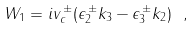<formula> <loc_0><loc_0><loc_500><loc_500>W _ { 1 } = i v _ { c } ^ { \, \pm } ( \epsilon _ { 2 } ^ { \, \pm } k _ { 3 } - \epsilon _ { 3 } ^ { \, \pm } k _ { 2 } ) \ ,</formula> 